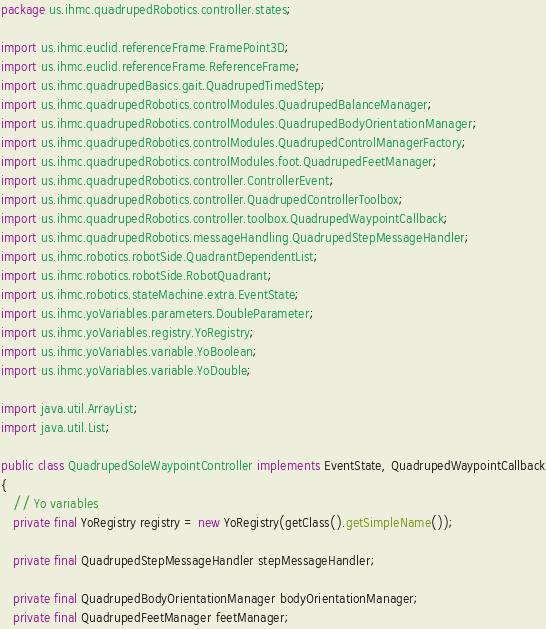<code> <loc_0><loc_0><loc_500><loc_500><_Java_>package us.ihmc.quadrupedRobotics.controller.states;

import us.ihmc.euclid.referenceFrame.FramePoint3D;
import us.ihmc.euclid.referenceFrame.ReferenceFrame;
import us.ihmc.quadrupedBasics.gait.QuadrupedTimedStep;
import us.ihmc.quadrupedRobotics.controlModules.QuadrupedBalanceManager;
import us.ihmc.quadrupedRobotics.controlModules.QuadrupedBodyOrientationManager;
import us.ihmc.quadrupedRobotics.controlModules.QuadrupedControlManagerFactory;
import us.ihmc.quadrupedRobotics.controlModules.foot.QuadrupedFeetManager;
import us.ihmc.quadrupedRobotics.controller.ControllerEvent;
import us.ihmc.quadrupedRobotics.controller.QuadrupedControllerToolbox;
import us.ihmc.quadrupedRobotics.controller.toolbox.QuadrupedWaypointCallback;
import us.ihmc.quadrupedRobotics.messageHandling.QuadrupedStepMessageHandler;
import us.ihmc.robotics.robotSide.QuadrantDependentList;
import us.ihmc.robotics.robotSide.RobotQuadrant;
import us.ihmc.robotics.stateMachine.extra.EventState;
import us.ihmc.yoVariables.parameters.DoubleParameter;
import us.ihmc.yoVariables.registry.YoRegistry;
import us.ihmc.yoVariables.variable.YoBoolean;
import us.ihmc.yoVariables.variable.YoDouble;

import java.util.ArrayList;
import java.util.List;

public class QuadrupedSoleWaypointController implements EventState, QuadrupedWaypointCallback
{
   // Yo variables
   private final YoRegistry registry = new YoRegistry(getClass().getSimpleName());

   private final QuadrupedStepMessageHandler stepMessageHandler;

   private final QuadrupedBodyOrientationManager bodyOrientationManager;
   private final QuadrupedFeetManager feetManager;</code> 